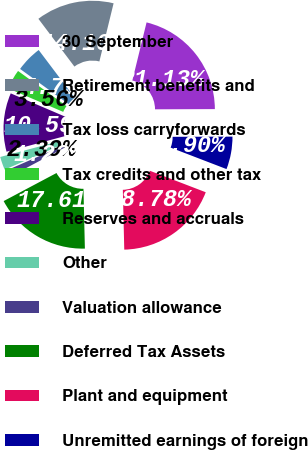<chart> <loc_0><loc_0><loc_500><loc_500><pie_chart><fcel>30 September<fcel>Retirement benefits and<fcel>Tax loss carryforwards<fcel>Tax credits and other tax<fcel>Reserves and accruals<fcel>Other<fcel>Valuation allowance<fcel>Deferred Tax Assets<fcel>Plant and equipment<fcel>Unremitted earnings of foreign<nl><fcel>21.13%<fcel>14.1%<fcel>4.73%<fcel>3.56%<fcel>10.59%<fcel>2.39%<fcel>1.22%<fcel>17.61%<fcel>18.78%<fcel>5.9%<nl></chart> 